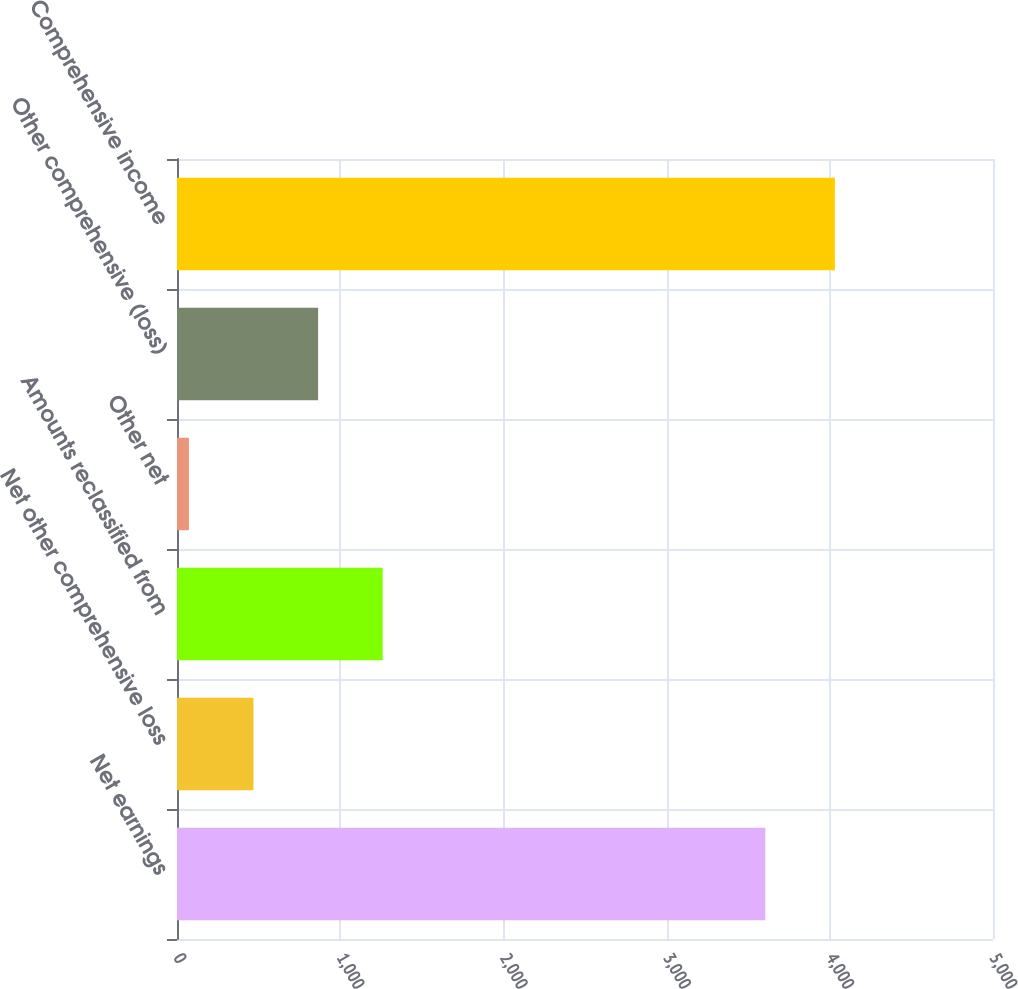Convert chart. <chart><loc_0><loc_0><loc_500><loc_500><bar_chart><fcel>Net earnings<fcel>Net other comprehensive loss<fcel>Amounts reclassified from<fcel>Other net<fcel>Other comprehensive (loss)<fcel>Comprehensive income<nl><fcel>3605<fcel>468.8<fcel>1260.4<fcel>73<fcel>864.6<fcel>4031<nl></chart> 